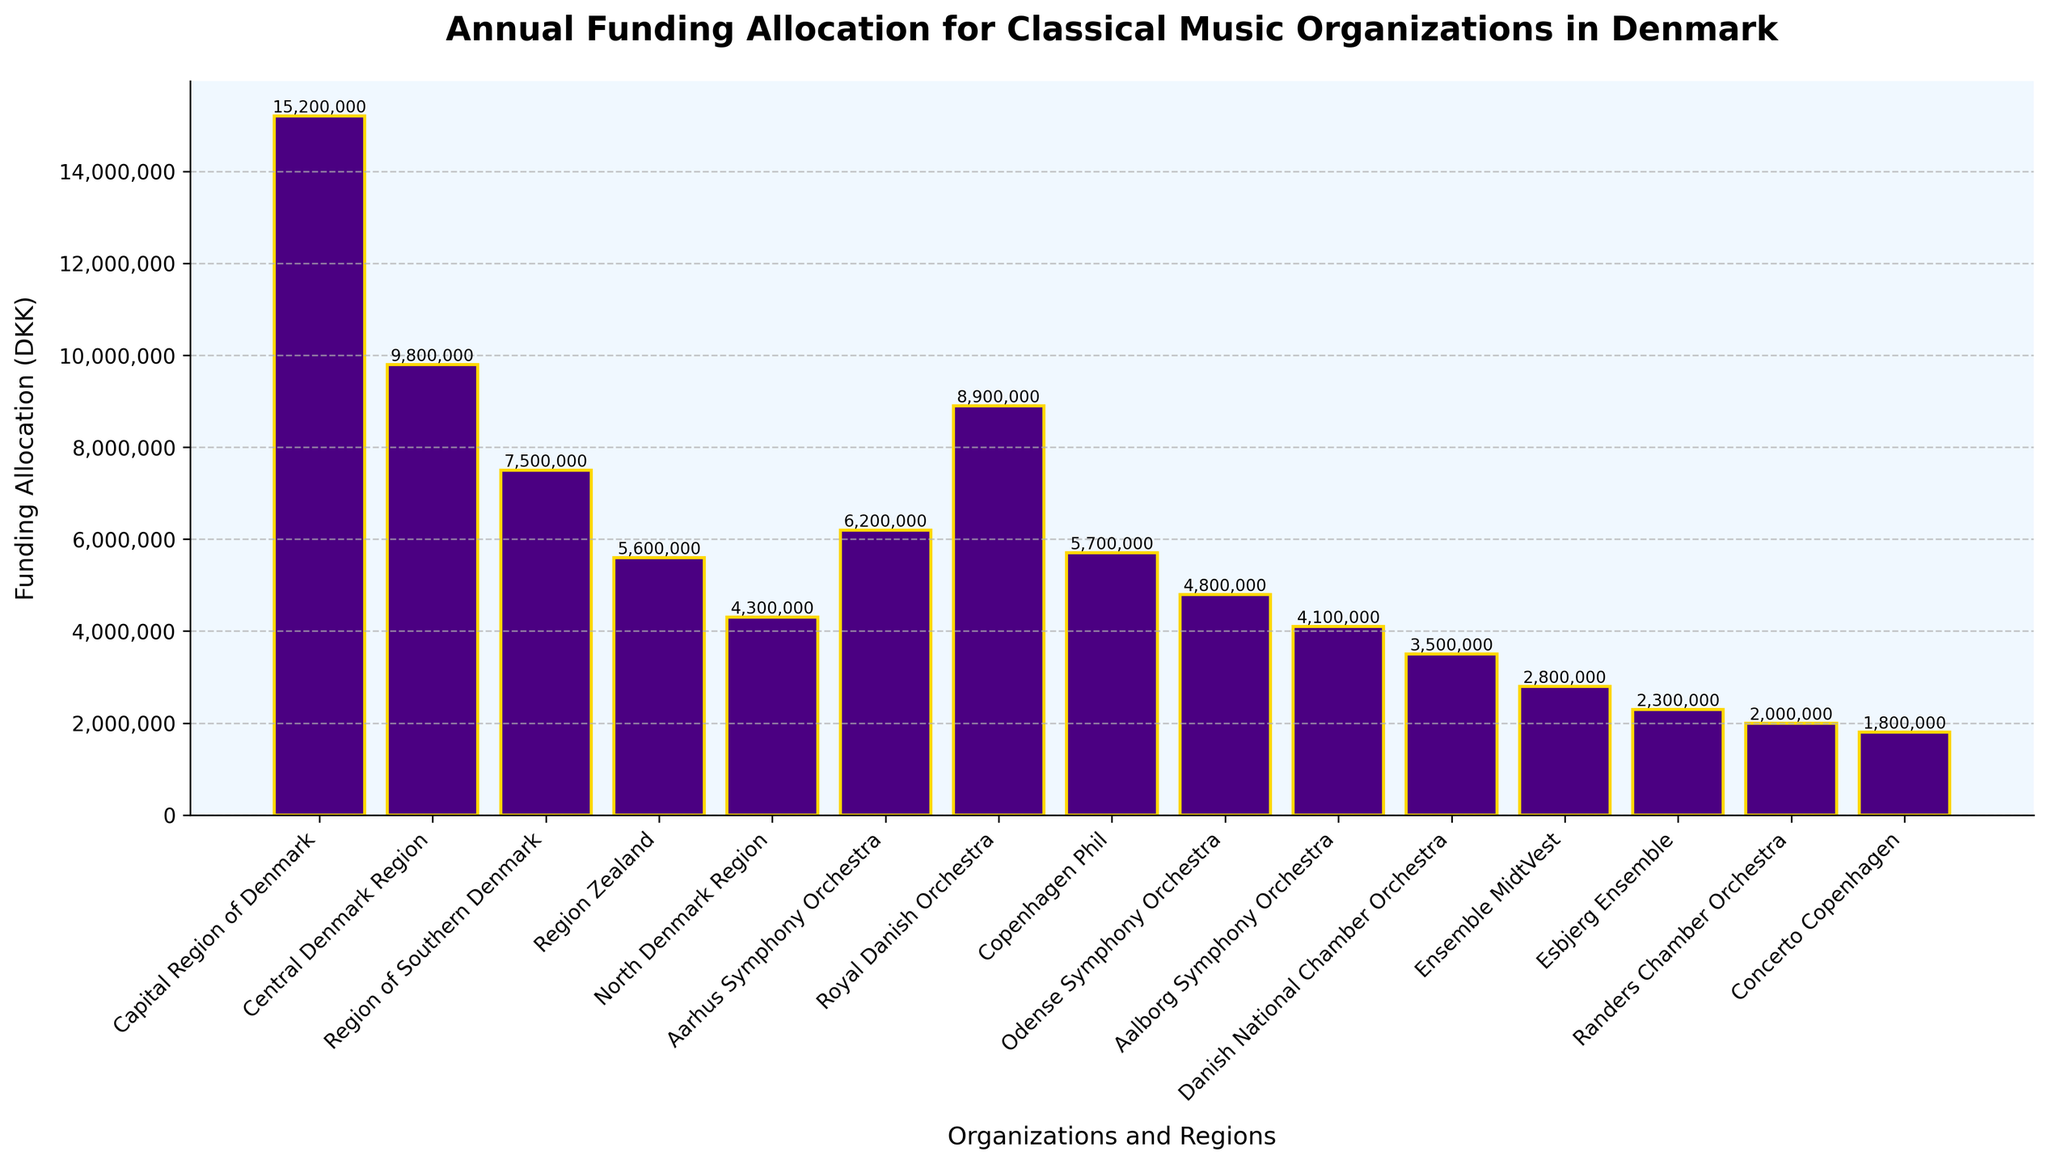How much more funding does the Capital Region of Denmark receive compared to the Region Zealand? The Capital Region of Denmark receives 15,200,000 DKK while Region Zealand receives 5,600,000 DKK. Subtracting the two values, 15,200,000 - 5,600,000, gives the difference in funding.
Answer: 9,600,000 DKK Which organization receives the least amount of funding? The bar representing Concerto Copenhagen appears to be the shortest, indicating that it receives the least funding.
Answer: Concerto Copenhagen What is the total funding allocation for the orchestras listed from Aarhus Symphony Orchestra to Randers Chamber Orchestra? Summing the funding allocations for Aarhus Symphony Orchestra (6,200,000), Royal Danish Orchestra (8,900,000), Copenhagen Phil (5,700,000), Odense Symphony Orchestra (4,800,000), Aalborg Symphony Orchestra (4,100,000), Danish National Chamber Orchestra (3,500,000), Ensemble MidtVest (2,800,000), Esbjerg Ensemble (2,300,000), and Randers Chamber Orchestra (2,000,000) results in the total funding. 6,200,000 + 8,900,000 + 5,700,000 + 4,800,000 + 4,100,000 + 3,500,000 + 2,800,000 + 2,300,000 + 2,000,000
Answer: 40,300,000 DKK Which region receives more funding, Central Denmark Region or North Denmark Region? Central Denmark Region receives 9,800,000 DKK while North Denmark Region receives 4,300,000 DKK. Comparing these two values, Central Denmark Region receives more funding.
Answer: Central Denmark Region Is the funding for the Odense Symphony Orchestra greater than 4,500,000 DKK? The bar for Odense Symphony Orchestra indicates a funding of 4,800,000 DKK, which is greater than 4,500,000 DKK.
Answer: Yes What is the median funding allocation for the listed organizations and regions? To find the median, list all the funding amounts in ascending order and locate the middle value. The sorted funding amounts are: 1,800,000 (Concerto Copenhagen), 2,000,000 (Randers Chamber Orchestra), 2,300,000 (Esbjerg Ensemble), 2,800,000 (Ensemble MidtVest), 3,500,000 (Danish National Chamber Orchestra), 4,100,000 (Aalborg Symphony Orchestra), 4,300,000 (North Denmark Region), 4,800,000 (Odense Symphony Orchestra), 5,600,000 (Region Zealand), 5,700,000 (Copenhagen Phil), 6,200,000 (Aarhus Symphony Orchestra), 7,500,000 (Region of Southern Denmark), 8,900,000 (Royal Danish Orchestra), 9,800,000 (Central Denmark Region), 15,200,000 (Capital Region of Denmark). The median value lies between the 8th and 9th numbers in the sorted list, hence (4,800,000 + 5,600,000)/2 = 5,200,000
Answer: 5,200,000 DKK Which bar is the tallest in the plot, and what does it represent? The tallest bar represents the Capital Region of Denmark, indicating it has the highest funding allocation of 15,200,000 DKK.
Answer: Capital Region of Denmark What is the average funding allocation for the five regions listed? Sum the funding allocations for the five regions (Capital Region of Denmark: 15,200,000, Central Denmark Region: 9,800,000, Region of Southern Denmark: 7,500,000, Region Zealand: 5,600,000, and North Denmark Region: 4,300,000) and divide by the number of regions. (15,200,000 + 9,800,000 + 7,500,000 + 5,600,000 + 4,300,000)/5
Answer: 8,080,000 DKK 